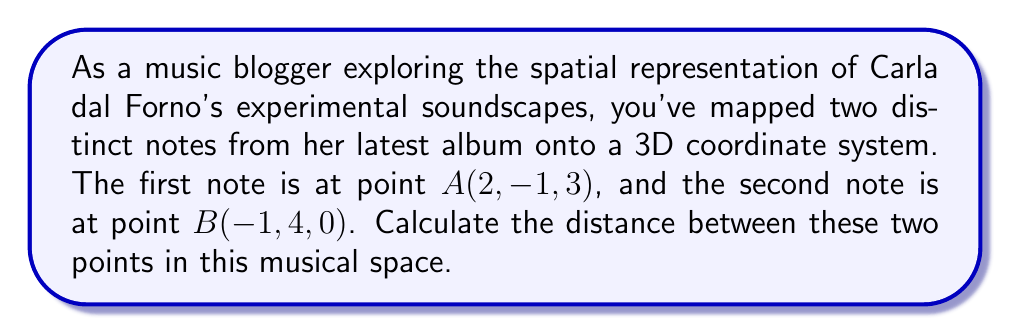Could you help me with this problem? To find the distance between two points in a 3D coordinate system, we use the distance formula derived from the Pythagorean theorem in three dimensions:

$$d = \sqrt{(x_2-x_1)^2 + (y_2-y_1)^2 + (z_2-z_1)^2}$$

Where $(x_1, y_1, z_1)$ are the coordinates of the first point and $(x_2, y_2, z_2)$ are the coordinates of the second point.

Given:
Point A: $(2, -1, 3)$
Point B: $(-1, 4, 0)$

Let's substitute these values into the formula:

$$\begin{align*}
d &= \sqrt{(-1-2)^2 + (4-(-1))^2 + (0-3)^2} \\
&= \sqrt{(-3)^2 + (5)^2 + (-3)^2} \\
&= \sqrt{9 + 25 + 9} \\
&= \sqrt{43}
\end{align*}$$

Therefore, the distance between the two notes in this 3D musical space is $\sqrt{43}$ units.
Answer: $\sqrt{43}$ units 